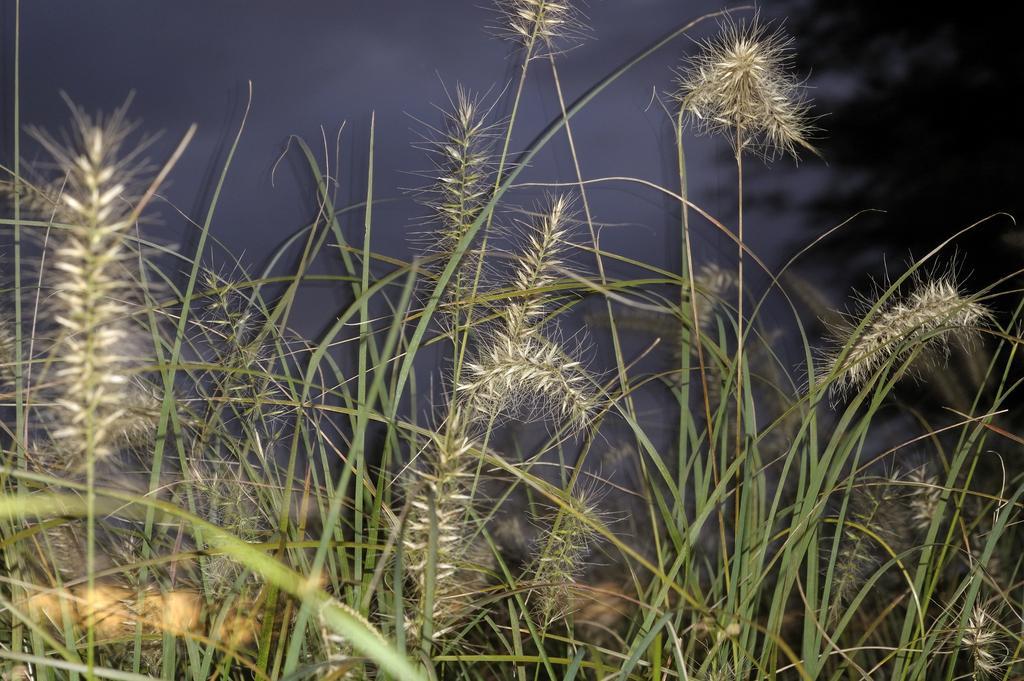How would you summarize this image in a sentence or two? In this image at the bottom there are some plants and on the top of the image there is sky, in the background there is one tree. 